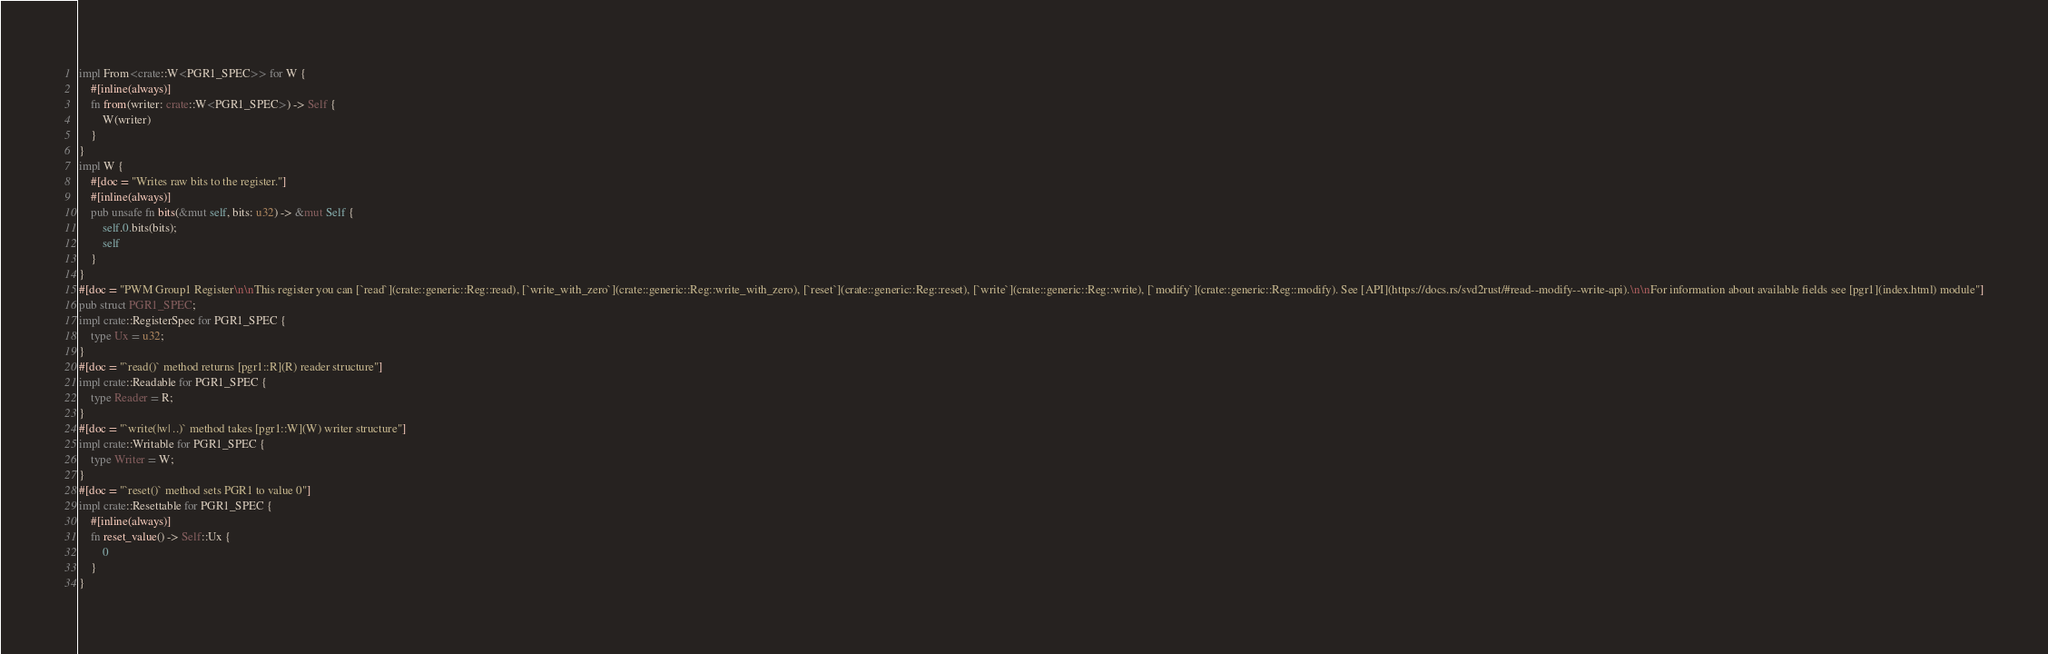Convert code to text. <code><loc_0><loc_0><loc_500><loc_500><_Rust_>impl From<crate::W<PGR1_SPEC>> for W {
    #[inline(always)]
    fn from(writer: crate::W<PGR1_SPEC>) -> Self {
        W(writer)
    }
}
impl W {
    #[doc = "Writes raw bits to the register."]
    #[inline(always)]
    pub unsafe fn bits(&mut self, bits: u32) -> &mut Self {
        self.0.bits(bits);
        self
    }
}
#[doc = "PWM Group1 Register\n\nThis register you can [`read`](crate::generic::Reg::read), [`write_with_zero`](crate::generic::Reg::write_with_zero), [`reset`](crate::generic::Reg::reset), [`write`](crate::generic::Reg::write), [`modify`](crate::generic::Reg::modify). See [API](https://docs.rs/svd2rust/#read--modify--write-api).\n\nFor information about available fields see [pgr1](index.html) module"]
pub struct PGR1_SPEC;
impl crate::RegisterSpec for PGR1_SPEC {
    type Ux = u32;
}
#[doc = "`read()` method returns [pgr1::R](R) reader structure"]
impl crate::Readable for PGR1_SPEC {
    type Reader = R;
}
#[doc = "`write(|w| ..)` method takes [pgr1::W](W) writer structure"]
impl crate::Writable for PGR1_SPEC {
    type Writer = W;
}
#[doc = "`reset()` method sets PGR1 to value 0"]
impl crate::Resettable for PGR1_SPEC {
    #[inline(always)]
    fn reset_value() -> Self::Ux {
        0
    }
}
</code> 